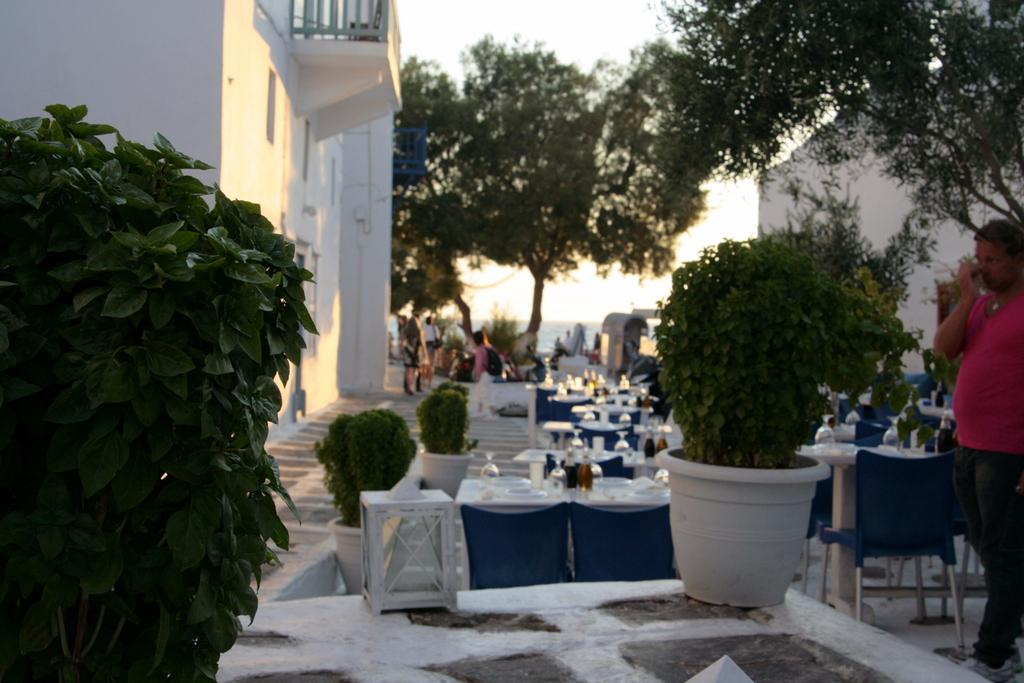What is the man in the image doing? The man in the image is walking. What type of vegetation can be seen in the image? There are bushes in the image. What type of furniture is present in the image? There are tables in the image. What type of plant is visible in the image? There is a tree in the image. What is visible in the background of the image? The sky is visible in the image. How many pigs are present in the image? There are no pigs present in the image. What type of writing instrument is the man holding in the image? The man is not holding any writing instrument in the image, such as a quill. 